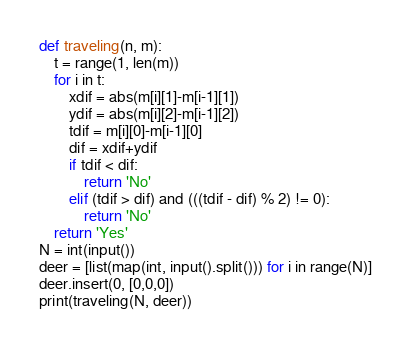<code> <loc_0><loc_0><loc_500><loc_500><_Python_>def traveling(n, m):
    t = range(1, len(m))
    for i in t:
        xdif = abs(m[i][1]-m[i-1][1])
        ydif = abs(m[i][2]-m[i-1][2])
        tdif = m[i][0]-m[i-1][0]
        dif = xdif+ydif
        if tdif < dif:
            return 'No'
        elif (tdif > dif) and (((tdif - dif) % 2) != 0):
            return 'No'
    return 'Yes'
N = int(input())
deer = [list(map(int, input().split())) for i in range(N)]
deer.insert(0, [0,0,0])
print(traveling(N, deer))</code> 